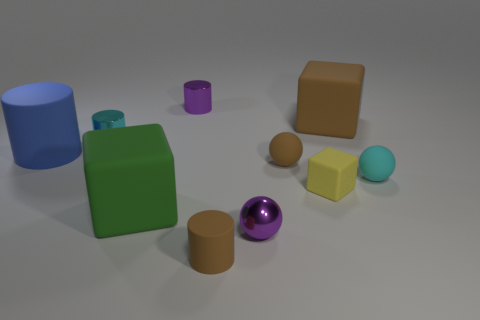There is a green thing that is the same material as the small brown cylinder; what size is it?
Your answer should be very brief. Large. The matte thing that is in front of the purple metal object that is in front of the small cyan ball is what color?
Offer a terse response. Brown. Is the number of tiny brown rubber cylinders greater than the number of tiny purple metal things?
Your response must be concise. No. What number of other cyan spheres are the same size as the cyan sphere?
Provide a short and direct response. 0. Is the material of the purple ball the same as the tiny purple object that is to the left of the small rubber cylinder?
Your response must be concise. Yes. Is the number of rubber blocks less than the number of cylinders?
Your response must be concise. Yes. Are there any other things that are the same color as the big cylinder?
Give a very brief answer. No. There is a green object that is the same material as the small cyan ball; what is its shape?
Your answer should be very brief. Cube. There is a rubber block behind the cyan object right of the green rubber object; what number of cyan shiny things are on the right side of it?
Your answer should be very brief. 0. What is the shape of the brown rubber thing that is behind the small cyan matte object and in front of the blue thing?
Keep it short and to the point. Sphere. 